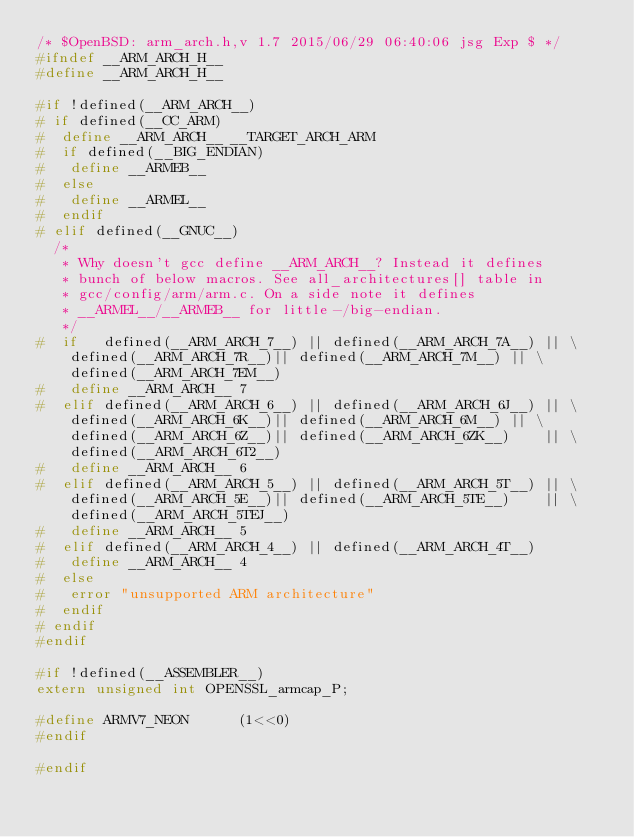<code> <loc_0><loc_0><loc_500><loc_500><_C_>/* $OpenBSD: arm_arch.h,v 1.7 2015/06/29 06:40:06 jsg Exp $ */
#ifndef __ARM_ARCH_H__
#define __ARM_ARCH_H__

#if !defined(__ARM_ARCH__)
# if defined(__CC_ARM)
#  define __ARM_ARCH__ __TARGET_ARCH_ARM
#  if defined(__BIG_ENDIAN)
#   define __ARMEB__
#  else
#   define __ARMEL__
#  endif
# elif defined(__GNUC__)
  /*
   * Why doesn't gcc define __ARM_ARCH__? Instead it defines
   * bunch of below macros. See all_architectures[] table in
   * gcc/config/arm/arm.c. On a side note it defines
   * __ARMEL__/__ARMEB__ for little-/big-endian.
   */
#  if	defined(__ARM_ARCH_7__)	|| defined(__ARM_ARCH_7A__)	|| \
	defined(__ARM_ARCH_7R__)|| defined(__ARM_ARCH_7M__)	|| \
	defined(__ARM_ARCH_7EM__)
#   define __ARM_ARCH__ 7
#  elif	defined(__ARM_ARCH_6__)	|| defined(__ARM_ARCH_6J__)	|| \
	defined(__ARM_ARCH_6K__)|| defined(__ARM_ARCH_6M__)	|| \
	defined(__ARM_ARCH_6Z__)|| defined(__ARM_ARCH_6ZK__)	|| \
	defined(__ARM_ARCH_6T2__)
#   define __ARM_ARCH__ 6
#  elif	defined(__ARM_ARCH_5__)	|| defined(__ARM_ARCH_5T__)	|| \
	defined(__ARM_ARCH_5E__)|| defined(__ARM_ARCH_5TE__)	|| \
	defined(__ARM_ARCH_5TEJ__)
#   define __ARM_ARCH__ 5
#  elif	defined(__ARM_ARCH_4__)	|| defined(__ARM_ARCH_4T__)
#   define __ARM_ARCH__ 4
#  else
#   error "unsupported ARM architecture"
#  endif
# endif
#endif

#if !defined(__ASSEMBLER__)
extern unsigned int OPENSSL_armcap_P;

#define ARMV7_NEON      (1<<0)
#endif

#endif
</code> 